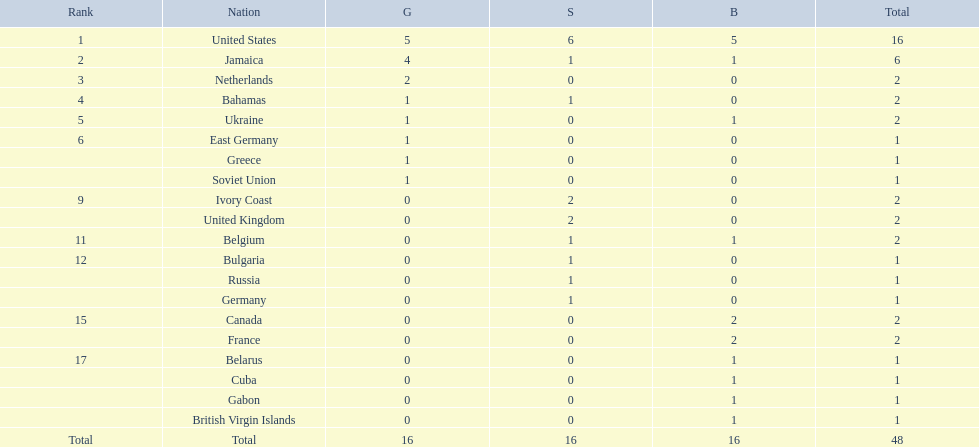What was the largest number of medals won by any country? 16. Which country won that many medals? United States. 